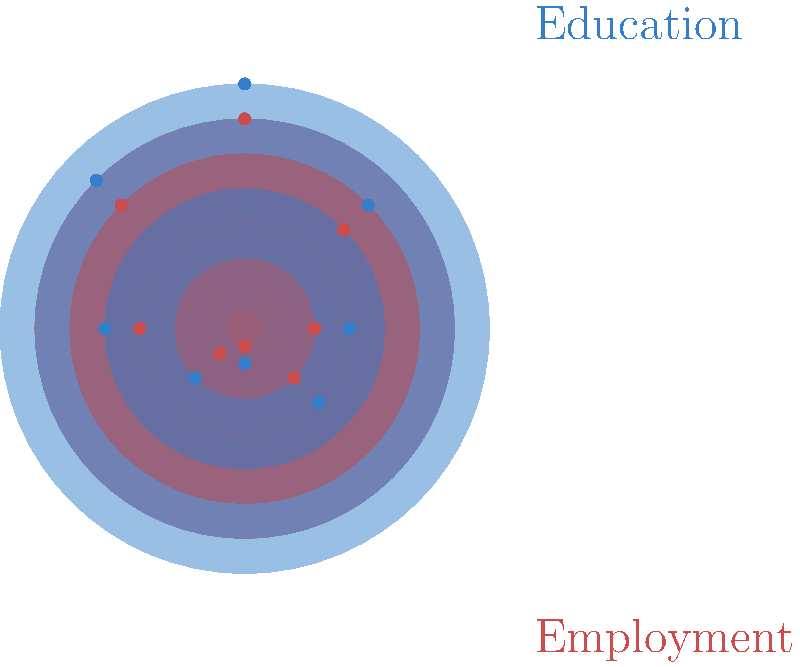In the polar area diagram above, education levels and employment rates in developing countries are represented. Which sector shows the strongest positive correlation between education and employment, and what policy implication can be drawn from this observation? To answer this question, we need to analyze the polar area diagram step-by-step:

1. Understand the diagram:
   - Blue areas represent education levels
   - Red areas represent employment rates
   - Each sector represents a different region or demographic group

2. Identify correlation:
   - Look for sectors where both education and employment areas are large or small together
   - The strongest positive correlation is where both areas are similarly sized and large

3. Analyze the sectors:
   - The sector at 45 degrees (top-right) shows the largest areas for both education and employment
   - This indicates the strongest positive correlation between education and employment

4. Interpret the finding:
   - In this region or demographic group, higher education levels correspond to higher employment rates

5. Draw policy implications:
   - Investing in education in this sector could lead to improved employment outcomes
   - This supports the idea that education can be a powerful tool for economic development and reducing marginalization

6. Consider the broader context:
   - As a policy analyst, this information suggests that targeted educational initiatives in this sector could be particularly effective in mitigating negative effects of globalization on marginalized populations
Answer: The 45-degree sector; invest in targeted education initiatives to improve employment outcomes and reduce marginalization. 